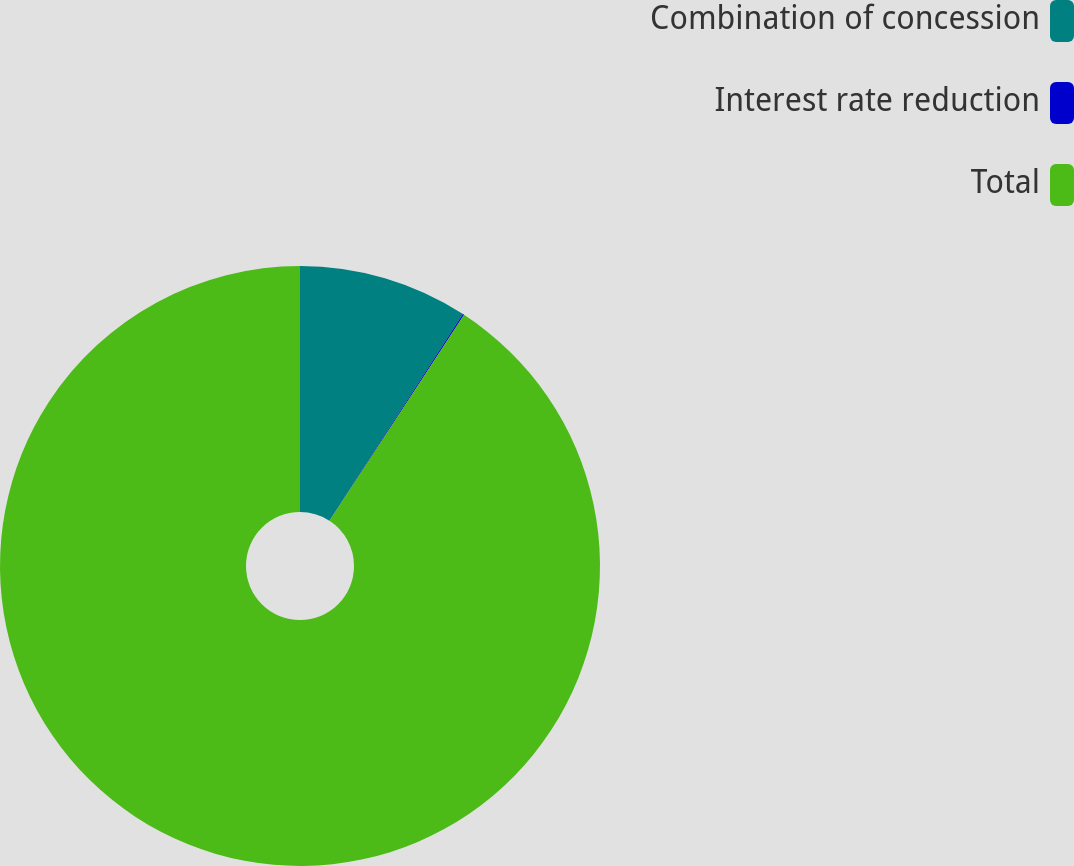<chart> <loc_0><loc_0><loc_500><loc_500><pie_chart><fcel>Combination of concession<fcel>Interest rate reduction<fcel>Total<nl><fcel>9.14%<fcel>0.07%<fcel>90.8%<nl></chart> 